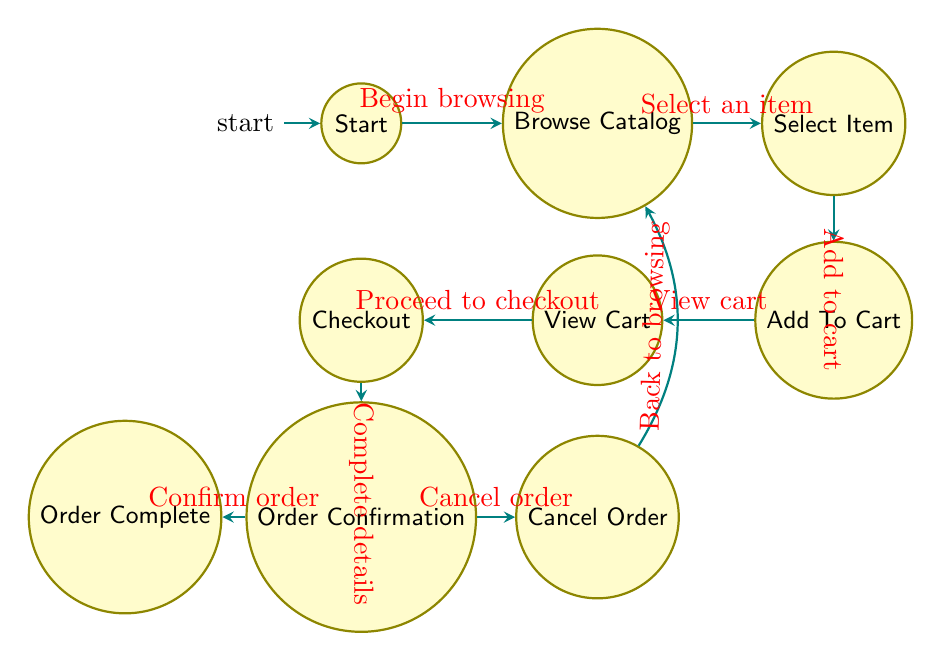What's the first state in the diagram? The diagram begins at the "Start" state, where the process to order merchandise initiates.
Answer: Start How many states are there in total? By counting all the nodes listed in the diagram, which includes Start, Browse Catalog, Select Item, Add To Cart, View Cart, Checkout, Order Confirmation, Order Complete, and Cancel Order, there are 9 states.
Answer: 9 What is the last state before order completion? The state immediately before completion, where the user reviews the order details for final confirmation, is "Order Confirmation."
Answer: Order Confirmation Which state follows "Add To Cart"? After the "Add To Cart" state, the natural progression leads to the "View Cart" state, where the user can review their selected items.
Answer: View Cart What transition occurs after "Cancel Order"? Following the "Cancel Order" state, the process transitions back to "Browse Catalog," allowing the user to continue shopping.
Answer: Browse Catalog If a user selects an item, which state do they go to next? After selecting an item, the next state in the sequence is the "Add To Cart" state, where the item can be added to their shopping list.
Answer: Add To Cart What happens after the user has completed their order confirmation? Once the user has confirmed their order, the final step is the "Order Complete" state, indicating the purchase has been finalized.
Answer: Order Complete What two transitions can occur from the "Order Confirmation" state? From "Order Confirmation," the user has two options: they can either confirm the order, leading to "Order Complete," or they can choose to cancel the order, transitioning to "Cancel Order."
Answer: Confirm order and Cancel order How does one get back to browsing from the cancel option? To return to browsing after canceling the order, the user initiates the transition labeled "Back to browsing," which directs them back to the "Browse Catalog" state.
Answer: Browse Catalog 